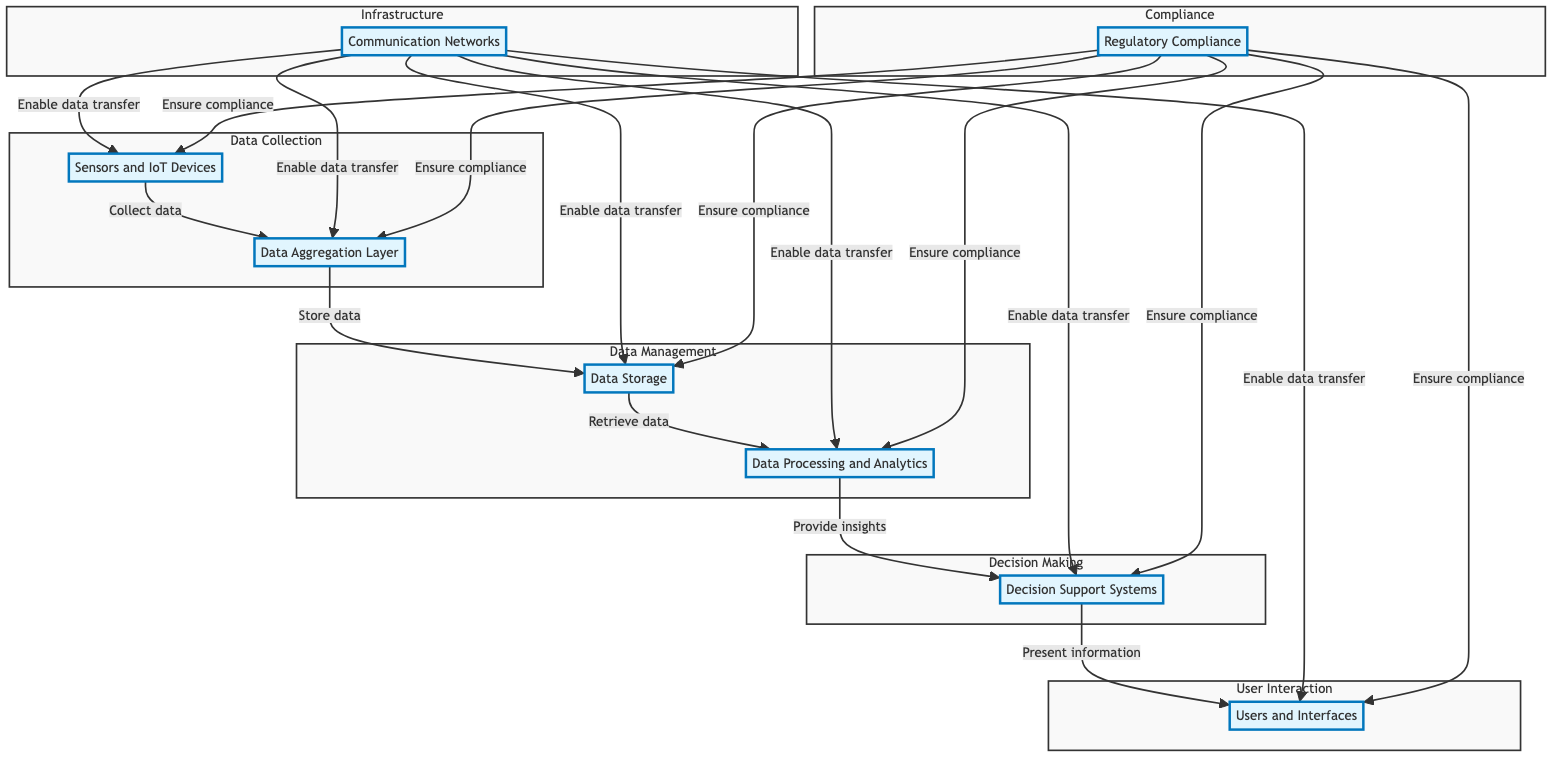What are the components involved in data collection? The diagram shows two components involved in data collection: Sensors and IoT Devices and Data Aggregation Layer.
Answer: Sensors and IoT Devices, Data Aggregation Layer How many main subgraphs are in the diagram? The diagram contains five main subgraphs: Data Collection, Data Management, Decision Making, Infrastructure, and User Interaction.
Answer: Five What is the purpose of the Data Aggregation Layer? The Data Aggregation Layer is responsible for collecting data from various field sensors and IoT devices.
Answer: Collecting data Which components are connected by the edge labeled "Store data"? The edge labeled "Store data" connects the Data Aggregation Layer to Data Storage.
Answer: Data Aggregation Layer, Data Storage What flows from Data Processing and Analytics to Decision Support Systems? Insights flow from Data Processing and Analytics to Decision Support Systems, providing actionable insights to aid decision-making.
Answer: Insights How does the Communication Network interact with the system? The Communication Network enables data transfer between multiple components: Sensors and IoT Devices, Data Aggregation Layer, Data Storage, Data Processing and Analytics, Decision Support Systems, and Users and Interfaces.
Answer: Enables data transfer What role does the Regulatory Compliance component play throughout the diagram? The Regulatory Compliance component ensures compliance across all components: Sensors and IoT Devices, Data Aggregation Layer, Data Storage, Data Processing and Analytics, Decision Support Systems, and Users and Interfaces.
Answer: Ensure compliance What type of analytics tools are mentioned in the diagram? The diagram mentions Big Data Analytics Platforms, Machine Learning Algorithms, and Visualization Tools as tools used for data processing and analytics.
Answer: Big Data Analytics Platforms, Machine Learning Algorithms, Visualization Tools How many interfaces do users have to interact with the system? Users and Interfaces provide various interaction points such as Mobile Apps, Web Dashboards, and Email Alerts to interact with the smart farming system.
Answer: Three 